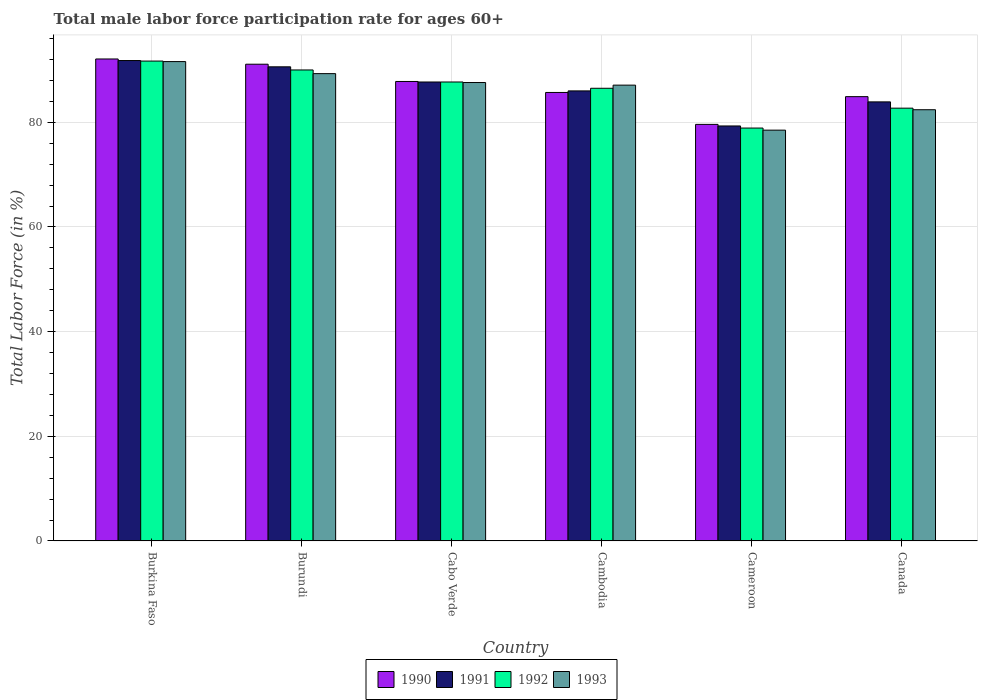How many different coloured bars are there?
Your answer should be very brief. 4. Are the number of bars per tick equal to the number of legend labels?
Offer a terse response. Yes. Are the number of bars on each tick of the X-axis equal?
Provide a succinct answer. Yes. How many bars are there on the 1st tick from the left?
Provide a short and direct response. 4. How many bars are there on the 3rd tick from the right?
Provide a short and direct response. 4. What is the label of the 1st group of bars from the left?
Offer a very short reply. Burkina Faso. What is the male labor force participation rate in 1991 in Burundi?
Your response must be concise. 90.6. Across all countries, what is the maximum male labor force participation rate in 1993?
Give a very brief answer. 91.6. Across all countries, what is the minimum male labor force participation rate in 1993?
Your answer should be very brief. 78.5. In which country was the male labor force participation rate in 1991 maximum?
Your answer should be compact. Burkina Faso. In which country was the male labor force participation rate in 1992 minimum?
Make the answer very short. Cameroon. What is the total male labor force participation rate in 1991 in the graph?
Make the answer very short. 519.3. What is the difference between the male labor force participation rate in 1991 in Cambodia and that in Cameroon?
Keep it short and to the point. 6.7. What is the difference between the male labor force participation rate in 1992 in Cabo Verde and the male labor force participation rate in 1993 in Canada?
Offer a very short reply. 5.3. What is the average male labor force participation rate in 1991 per country?
Offer a terse response. 86.55. What is the ratio of the male labor force participation rate in 1990 in Cabo Verde to that in Canada?
Offer a very short reply. 1.03. Is the male labor force participation rate in 1993 in Burundi less than that in Cameroon?
Your response must be concise. No. Is the difference between the male labor force participation rate in 1992 in Burkina Faso and Cameroon greater than the difference between the male labor force participation rate in 1991 in Burkina Faso and Cameroon?
Offer a terse response. Yes. What is the difference between the highest and the second highest male labor force participation rate in 1992?
Offer a terse response. -1.7. What is the difference between the highest and the lowest male labor force participation rate in 1993?
Your answer should be compact. 13.1. Is it the case that in every country, the sum of the male labor force participation rate in 1992 and male labor force participation rate in 1990 is greater than the sum of male labor force participation rate in 1993 and male labor force participation rate in 1991?
Offer a very short reply. No. What does the 1st bar from the left in Cabo Verde represents?
Provide a short and direct response. 1990. How many countries are there in the graph?
Keep it short and to the point. 6. What is the difference between two consecutive major ticks on the Y-axis?
Provide a succinct answer. 20. Does the graph contain grids?
Keep it short and to the point. Yes. What is the title of the graph?
Keep it short and to the point. Total male labor force participation rate for ages 60+. Does "2003" appear as one of the legend labels in the graph?
Provide a short and direct response. No. What is the label or title of the Y-axis?
Provide a short and direct response. Total Labor Force (in %). What is the Total Labor Force (in %) of 1990 in Burkina Faso?
Make the answer very short. 92.1. What is the Total Labor Force (in %) of 1991 in Burkina Faso?
Offer a terse response. 91.8. What is the Total Labor Force (in %) of 1992 in Burkina Faso?
Ensure brevity in your answer.  91.7. What is the Total Labor Force (in %) in 1993 in Burkina Faso?
Give a very brief answer. 91.6. What is the Total Labor Force (in %) of 1990 in Burundi?
Your answer should be very brief. 91.1. What is the Total Labor Force (in %) of 1991 in Burundi?
Ensure brevity in your answer.  90.6. What is the Total Labor Force (in %) in 1993 in Burundi?
Offer a terse response. 89.3. What is the Total Labor Force (in %) of 1990 in Cabo Verde?
Your response must be concise. 87.8. What is the Total Labor Force (in %) in 1991 in Cabo Verde?
Provide a succinct answer. 87.7. What is the Total Labor Force (in %) in 1992 in Cabo Verde?
Ensure brevity in your answer.  87.7. What is the Total Labor Force (in %) in 1993 in Cabo Verde?
Make the answer very short. 87.6. What is the Total Labor Force (in %) in 1990 in Cambodia?
Provide a succinct answer. 85.7. What is the Total Labor Force (in %) in 1992 in Cambodia?
Offer a terse response. 86.5. What is the Total Labor Force (in %) of 1993 in Cambodia?
Provide a short and direct response. 87.1. What is the Total Labor Force (in %) of 1990 in Cameroon?
Your response must be concise. 79.6. What is the Total Labor Force (in %) of 1991 in Cameroon?
Provide a short and direct response. 79.3. What is the Total Labor Force (in %) in 1992 in Cameroon?
Provide a succinct answer. 78.9. What is the Total Labor Force (in %) in 1993 in Cameroon?
Offer a terse response. 78.5. What is the Total Labor Force (in %) in 1990 in Canada?
Provide a succinct answer. 84.9. What is the Total Labor Force (in %) of 1991 in Canada?
Your answer should be compact. 83.9. What is the Total Labor Force (in %) of 1992 in Canada?
Offer a terse response. 82.7. What is the Total Labor Force (in %) in 1993 in Canada?
Offer a terse response. 82.4. Across all countries, what is the maximum Total Labor Force (in %) of 1990?
Offer a very short reply. 92.1. Across all countries, what is the maximum Total Labor Force (in %) of 1991?
Ensure brevity in your answer.  91.8. Across all countries, what is the maximum Total Labor Force (in %) of 1992?
Your answer should be compact. 91.7. Across all countries, what is the maximum Total Labor Force (in %) in 1993?
Your answer should be compact. 91.6. Across all countries, what is the minimum Total Labor Force (in %) of 1990?
Keep it short and to the point. 79.6. Across all countries, what is the minimum Total Labor Force (in %) in 1991?
Give a very brief answer. 79.3. Across all countries, what is the minimum Total Labor Force (in %) in 1992?
Make the answer very short. 78.9. Across all countries, what is the minimum Total Labor Force (in %) in 1993?
Ensure brevity in your answer.  78.5. What is the total Total Labor Force (in %) of 1990 in the graph?
Provide a succinct answer. 521.2. What is the total Total Labor Force (in %) in 1991 in the graph?
Provide a short and direct response. 519.3. What is the total Total Labor Force (in %) in 1992 in the graph?
Your answer should be very brief. 517.5. What is the total Total Labor Force (in %) of 1993 in the graph?
Make the answer very short. 516.5. What is the difference between the Total Labor Force (in %) of 1990 in Burkina Faso and that in Cabo Verde?
Make the answer very short. 4.3. What is the difference between the Total Labor Force (in %) of 1992 in Burkina Faso and that in Cabo Verde?
Offer a terse response. 4. What is the difference between the Total Labor Force (in %) in 1993 in Burkina Faso and that in Cabo Verde?
Your answer should be compact. 4. What is the difference between the Total Labor Force (in %) of 1990 in Burkina Faso and that in Cambodia?
Your answer should be very brief. 6.4. What is the difference between the Total Labor Force (in %) of 1991 in Burkina Faso and that in Cambodia?
Provide a short and direct response. 5.8. What is the difference between the Total Labor Force (in %) of 1993 in Burkina Faso and that in Cambodia?
Your response must be concise. 4.5. What is the difference between the Total Labor Force (in %) in 1990 in Burkina Faso and that in Cameroon?
Give a very brief answer. 12.5. What is the difference between the Total Labor Force (in %) of 1993 in Burkina Faso and that in Cameroon?
Offer a terse response. 13.1. What is the difference between the Total Labor Force (in %) in 1990 in Burkina Faso and that in Canada?
Your answer should be compact. 7.2. What is the difference between the Total Labor Force (in %) in 1992 in Burkina Faso and that in Canada?
Your response must be concise. 9. What is the difference between the Total Labor Force (in %) of 1990 in Burundi and that in Cabo Verde?
Offer a terse response. 3.3. What is the difference between the Total Labor Force (in %) of 1991 in Burundi and that in Cabo Verde?
Your answer should be compact. 2.9. What is the difference between the Total Labor Force (in %) in 1992 in Burundi and that in Cabo Verde?
Your answer should be very brief. 2.3. What is the difference between the Total Labor Force (in %) in 1993 in Burundi and that in Cabo Verde?
Ensure brevity in your answer.  1.7. What is the difference between the Total Labor Force (in %) in 1990 in Burundi and that in Cambodia?
Ensure brevity in your answer.  5.4. What is the difference between the Total Labor Force (in %) of 1993 in Burundi and that in Cambodia?
Give a very brief answer. 2.2. What is the difference between the Total Labor Force (in %) in 1990 in Burundi and that in Cameroon?
Provide a succinct answer. 11.5. What is the difference between the Total Labor Force (in %) of 1993 in Burundi and that in Canada?
Provide a short and direct response. 6.9. What is the difference between the Total Labor Force (in %) in 1991 in Cabo Verde and that in Cambodia?
Give a very brief answer. 1.7. What is the difference between the Total Labor Force (in %) of 1992 in Cabo Verde and that in Cambodia?
Ensure brevity in your answer.  1.2. What is the difference between the Total Labor Force (in %) of 1993 in Cabo Verde and that in Cambodia?
Provide a short and direct response. 0.5. What is the difference between the Total Labor Force (in %) of 1990 in Cabo Verde and that in Cameroon?
Give a very brief answer. 8.2. What is the difference between the Total Labor Force (in %) of 1991 in Cabo Verde and that in Cameroon?
Give a very brief answer. 8.4. What is the difference between the Total Labor Force (in %) in 1993 in Cabo Verde and that in Cameroon?
Ensure brevity in your answer.  9.1. What is the difference between the Total Labor Force (in %) of 1990 in Cabo Verde and that in Canada?
Give a very brief answer. 2.9. What is the difference between the Total Labor Force (in %) in 1991 in Cabo Verde and that in Canada?
Provide a succinct answer. 3.8. What is the difference between the Total Labor Force (in %) in 1991 in Cambodia and that in Cameroon?
Keep it short and to the point. 6.7. What is the difference between the Total Labor Force (in %) of 1990 in Cambodia and that in Canada?
Keep it short and to the point. 0.8. What is the difference between the Total Labor Force (in %) of 1992 in Cambodia and that in Canada?
Your response must be concise. 3.8. What is the difference between the Total Labor Force (in %) in 1990 in Cameroon and that in Canada?
Keep it short and to the point. -5.3. What is the difference between the Total Labor Force (in %) in 1993 in Cameroon and that in Canada?
Provide a short and direct response. -3.9. What is the difference between the Total Labor Force (in %) in 1991 in Burkina Faso and the Total Labor Force (in %) in 1993 in Burundi?
Ensure brevity in your answer.  2.5. What is the difference between the Total Labor Force (in %) of 1992 in Burkina Faso and the Total Labor Force (in %) of 1993 in Burundi?
Keep it short and to the point. 2.4. What is the difference between the Total Labor Force (in %) in 1990 in Burkina Faso and the Total Labor Force (in %) in 1991 in Cabo Verde?
Make the answer very short. 4.4. What is the difference between the Total Labor Force (in %) in 1990 in Burkina Faso and the Total Labor Force (in %) in 1993 in Cabo Verde?
Your response must be concise. 4.5. What is the difference between the Total Labor Force (in %) of 1992 in Burkina Faso and the Total Labor Force (in %) of 1993 in Cabo Verde?
Ensure brevity in your answer.  4.1. What is the difference between the Total Labor Force (in %) of 1990 in Burkina Faso and the Total Labor Force (in %) of 1991 in Cambodia?
Give a very brief answer. 6.1. What is the difference between the Total Labor Force (in %) of 1991 in Burkina Faso and the Total Labor Force (in %) of 1993 in Cambodia?
Make the answer very short. 4.7. What is the difference between the Total Labor Force (in %) in 1992 in Burkina Faso and the Total Labor Force (in %) in 1993 in Cambodia?
Keep it short and to the point. 4.6. What is the difference between the Total Labor Force (in %) of 1990 in Burkina Faso and the Total Labor Force (in %) of 1991 in Cameroon?
Provide a succinct answer. 12.8. What is the difference between the Total Labor Force (in %) in 1991 in Burkina Faso and the Total Labor Force (in %) in 1992 in Cameroon?
Your answer should be very brief. 12.9. What is the difference between the Total Labor Force (in %) in 1991 in Burkina Faso and the Total Labor Force (in %) in 1993 in Cameroon?
Offer a very short reply. 13.3. What is the difference between the Total Labor Force (in %) in 1990 in Burkina Faso and the Total Labor Force (in %) in 1992 in Canada?
Provide a short and direct response. 9.4. What is the difference between the Total Labor Force (in %) in 1990 in Burkina Faso and the Total Labor Force (in %) in 1993 in Canada?
Provide a short and direct response. 9.7. What is the difference between the Total Labor Force (in %) in 1991 in Burkina Faso and the Total Labor Force (in %) in 1992 in Canada?
Make the answer very short. 9.1. What is the difference between the Total Labor Force (in %) in 1990 in Burundi and the Total Labor Force (in %) in 1993 in Cabo Verde?
Make the answer very short. 3.5. What is the difference between the Total Labor Force (in %) in 1991 in Burundi and the Total Labor Force (in %) in 1992 in Cabo Verde?
Offer a terse response. 2.9. What is the difference between the Total Labor Force (in %) in 1990 in Burundi and the Total Labor Force (in %) in 1992 in Cambodia?
Your response must be concise. 4.6. What is the difference between the Total Labor Force (in %) of 1991 in Burundi and the Total Labor Force (in %) of 1992 in Cambodia?
Provide a succinct answer. 4.1. What is the difference between the Total Labor Force (in %) in 1990 in Burundi and the Total Labor Force (in %) in 1991 in Cameroon?
Your answer should be very brief. 11.8. What is the difference between the Total Labor Force (in %) in 1992 in Burundi and the Total Labor Force (in %) in 1993 in Cameroon?
Offer a terse response. 11.5. What is the difference between the Total Labor Force (in %) of 1990 in Burundi and the Total Labor Force (in %) of 1991 in Canada?
Make the answer very short. 7.2. What is the difference between the Total Labor Force (in %) of 1990 in Burundi and the Total Labor Force (in %) of 1992 in Canada?
Make the answer very short. 8.4. What is the difference between the Total Labor Force (in %) in 1990 in Burundi and the Total Labor Force (in %) in 1993 in Canada?
Offer a very short reply. 8.7. What is the difference between the Total Labor Force (in %) in 1990 in Cabo Verde and the Total Labor Force (in %) in 1991 in Cameroon?
Provide a short and direct response. 8.5. What is the difference between the Total Labor Force (in %) of 1990 in Cabo Verde and the Total Labor Force (in %) of 1992 in Cameroon?
Your answer should be compact. 8.9. What is the difference between the Total Labor Force (in %) of 1991 in Cabo Verde and the Total Labor Force (in %) of 1992 in Cameroon?
Keep it short and to the point. 8.8. What is the difference between the Total Labor Force (in %) in 1990 in Cabo Verde and the Total Labor Force (in %) in 1991 in Canada?
Your response must be concise. 3.9. What is the difference between the Total Labor Force (in %) in 1990 in Cambodia and the Total Labor Force (in %) in 1993 in Cameroon?
Make the answer very short. 7.2. What is the difference between the Total Labor Force (in %) of 1991 in Cambodia and the Total Labor Force (in %) of 1992 in Cameroon?
Offer a terse response. 7.1. What is the difference between the Total Labor Force (in %) in 1992 in Cambodia and the Total Labor Force (in %) in 1993 in Cameroon?
Your response must be concise. 8. What is the difference between the Total Labor Force (in %) in 1990 in Cambodia and the Total Labor Force (in %) in 1991 in Canada?
Make the answer very short. 1.8. What is the difference between the Total Labor Force (in %) of 1990 in Cambodia and the Total Labor Force (in %) of 1992 in Canada?
Your response must be concise. 3. What is the difference between the Total Labor Force (in %) of 1990 in Cambodia and the Total Labor Force (in %) of 1993 in Canada?
Your answer should be compact. 3.3. What is the difference between the Total Labor Force (in %) in 1991 in Cambodia and the Total Labor Force (in %) in 1992 in Canada?
Offer a terse response. 3.3. What is the difference between the Total Labor Force (in %) of 1991 in Cambodia and the Total Labor Force (in %) of 1993 in Canada?
Provide a short and direct response. 3.6. What is the difference between the Total Labor Force (in %) of 1992 in Cambodia and the Total Labor Force (in %) of 1993 in Canada?
Your answer should be very brief. 4.1. What is the difference between the Total Labor Force (in %) of 1990 in Cameroon and the Total Labor Force (in %) of 1991 in Canada?
Keep it short and to the point. -4.3. What is the difference between the Total Labor Force (in %) of 1990 in Cameroon and the Total Labor Force (in %) of 1992 in Canada?
Offer a terse response. -3.1. What is the difference between the Total Labor Force (in %) of 1990 in Cameroon and the Total Labor Force (in %) of 1993 in Canada?
Your response must be concise. -2.8. What is the average Total Labor Force (in %) of 1990 per country?
Offer a very short reply. 86.87. What is the average Total Labor Force (in %) of 1991 per country?
Provide a succinct answer. 86.55. What is the average Total Labor Force (in %) in 1992 per country?
Provide a succinct answer. 86.25. What is the average Total Labor Force (in %) of 1993 per country?
Provide a short and direct response. 86.08. What is the difference between the Total Labor Force (in %) of 1990 and Total Labor Force (in %) of 1991 in Burundi?
Your answer should be very brief. 0.5. What is the difference between the Total Labor Force (in %) of 1990 and Total Labor Force (in %) of 1992 in Burundi?
Keep it short and to the point. 1.1. What is the difference between the Total Labor Force (in %) of 1990 and Total Labor Force (in %) of 1993 in Burundi?
Provide a short and direct response. 1.8. What is the difference between the Total Labor Force (in %) of 1990 and Total Labor Force (in %) of 1991 in Cabo Verde?
Provide a succinct answer. 0.1. What is the difference between the Total Labor Force (in %) in 1990 and Total Labor Force (in %) in 1992 in Cabo Verde?
Make the answer very short. 0.1. What is the difference between the Total Labor Force (in %) of 1991 and Total Labor Force (in %) of 1993 in Cabo Verde?
Your answer should be compact. 0.1. What is the difference between the Total Labor Force (in %) of 1992 and Total Labor Force (in %) of 1993 in Cabo Verde?
Offer a very short reply. 0.1. What is the difference between the Total Labor Force (in %) in 1990 and Total Labor Force (in %) in 1993 in Cambodia?
Make the answer very short. -1.4. What is the difference between the Total Labor Force (in %) in 1991 and Total Labor Force (in %) in 1992 in Cambodia?
Your answer should be very brief. -0.5. What is the difference between the Total Labor Force (in %) in 1992 and Total Labor Force (in %) in 1993 in Cambodia?
Provide a short and direct response. -0.6. What is the difference between the Total Labor Force (in %) in 1991 and Total Labor Force (in %) in 1993 in Cameroon?
Your answer should be very brief. 0.8. What is the difference between the Total Labor Force (in %) in 1990 and Total Labor Force (in %) in 1991 in Canada?
Your response must be concise. 1. What is the difference between the Total Labor Force (in %) in 1990 and Total Labor Force (in %) in 1992 in Canada?
Provide a succinct answer. 2.2. What is the difference between the Total Labor Force (in %) in 1990 and Total Labor Force (in %) in 1993 in Canada?
Your answer should be very brief. 2.5. What is the ratio of the Total Labor Force (in %) in 1990 in Burkina Faso to that in Burundi?
Keep it short and to the point. 1.01. What is the ratio of the Total Labor Force (in %) in 1991 in Burkina Faso to that in Burundi?
Provide a succinct answer. 1.01. What is the ratio of the Total Labor Force (in %) in 1992 in Burkina Faso to that in Burundi?
Your response must be concise. 1.02. What is the ratio of the Total Labor Force (in %) in 1993 in Burkina Faso to that in Burundi?
Ensure brevity in your answer.  1.03. What is the ratio of the Total Labor Force (in %) of 1990 in Burkina Faso to that in Cabo Verde?
Offer a terse response. 1.05. What is the ratio of the Total Labor Force (in %) of 1991 in Burkina Faso to that in Cabo Verde?
Your response must be concise. 1.05. What is the ratio of the Total Labor Force (in %) in 1992 in Burkina Faso to that in Cabo Verde?
Your answer should be very brief. 1.05. What is the ratio of the Total Labor Force (in %) of 1993 in Burkina Faso to that in Cabo Verde?
Your answer should be very brief. 1.05. What is the ratio of the Total Labor Force (in %) of 1990 in Burkina Faso to that in Cambodia?
Offer a terse response. 1.07. What is the ratio of the Total Labor Force (in %) of 1991 in Burkina Faso to that in Cambodia?
Keep it short and to the point. 1.07. What is the ratio of the Total Labor Force (in %) in 1992 in Burkina Faso to that in Cambodia?
Ensure brevity in your answer.  1.06. What is the ratio of the Total Labor Force (in %) of 1993 in Burkina Faso to that in Cambodia?
Offer a terse response. 1.05. What is the ratio of the Total Labor Force (in %) in 1990 in Burkina Faso to that in Cameroon?
Your answer should be very brief. 1.16. What is the ratio of the Total Labor Force (in %) in 1991 in Burkina Faso to that in Cameroon?
Provide a short and direct response. 1.16. What is the ratio of the Total Labor Force (in %) of 1992 in Burkina Faso to that in Cameroon?
Make the answer very short. 1.16. What is the ratio of the Total Labor Force (in %) in 1993 in Burkina Faso to that in Cameroon?
Provide a short and direct response. 1.17. What is the ratio of the Total Labor Force (in %) of 1990 in Burkina Faso to that in Canada?
Provide a succinct answer. 1.08. What is the ratio of the Total Labor Force (in %) of 1991 in Burkina Faso to that in Canada?
Provide a short and direct response. 1.09. What is the ratio of the Total Labor Force (in %) in 1992 in Burkina Faso to that in Canada?
Ensure brevity in your answer.  1.11. What is the ratio of the Total Labor Force (in %) in 1993 in Burkina Faso to that in Canada?
Ensure brevity in your answer.  1.11. What is the ratio of the Total Labor Force (in %) in 1990 in Burundi to that in Cabo Verde?
Provide a short and direct response. 1.04. What is the ratio of the Total Labor Force (in %) of 1991 in Burundi to that in Cabo Verde?
Give a very brief answer. 1.03. What is the ratio of the Total Labor Force (in %) of 1992 in Burundi to that in Cabo Verde?
Provide a succinct answer. 1.03. What is the ratio of the Total Labor Force (in %) in 1993 in Burundi to that in Cabo Verde?
Provide a short and direct response. 1.02. What is the ratio of the Total Labor Force (in %) of 1990 in Burundi to that in Cambodia?
Make the answer very short. 1.06. What is the ratio of the Total Labor Force (in %) in 1991 in Burundi to that in Cambodia?
Offer a terse response. 1.05. What is the ratio of the Total Labor Force (in %) of 1992 in Burundi to that in Cambodia?
Provide a succinct answer. 1.04. What is the ratio of the Total Labor Force (in %) of 1993 in Burundi to that in Cambodia?
Make the answer very short. 1.03. What is the ratio of the Total Labor Force (in %) of 1990 in Burundi to that in Cameroon?
Offer a terse response. 1.14. What is the ratio of the Total Labor Force (in %) in 1991 in Burundi to that in Cameroon?
Ensure brevity in your answer.  1.14. What is the ratio of the Total Labor Force (in %) in 1992 in Burundi to that in Cameroon?
Give a very brief answer. 1.14. What is the ratio of the Total Labor Force (in %) of 1993 in Burundi to that in Cameroon?
Give a very brief answer. 1.14. What is the ratio of the Total Labor Force (in %) in 1990 in Burundi to that in Canada?
Provide a succinct answer. 1.07. What is the ratio of the Total Labor Force (in %) in 1991 in Burundi to that in Canada?
Provide a succinct answer. 1.08. What is the ratio of the Total Labor Force (in %) in 1992 in Burundi to that in Canada?
Make the answer very short. 1.09. What is the ratio of the Total Labor Force (in %) of 1993 in Burundi to that in Canada?
Your answer should be very brief. 1.08. What is the ratio of the Total Labor Force (in %) of 1990 in Cabo Verde to that in Cambodia?
Provide a succinct answer. 1.02. What is the ratio of the Total Labor Force (in %) of 1991 in Cabo Verde to that in Cambodia?
Your answer should be compact. 1.02. What is the ratio of the Total Labor Force (in %) of 1992 in Cabo Verde to that in Cambodia?
Keep it short and to the point. 1.01. What is the ratio of the Total Labor Force (in %) in 1993 in Cabo Verde to that in Cambodia?
Keep it short and to the point. 1.01. What is the ratio of the Total Labor Force (in %) in 1990 in Cabo Verde to that in Cameroon?
Your response must be concise. 1.1. What is the ratio of the Total Labor Force (in %) of 1991 in Cabo Verde to that in Cameroon?
Offer a terse response. 1.11. What is the ratio of the Total Labor Force (in %) in 1992 in Cabo Verde to that in Cameroon?
Provide a short and direct response. 1.11. What is the ratio of the Total Labor Force (in %) of 1993 in Cabo Verde to that in Cameroon?
Make the answer very short. 1.12. What is the ratio of the Total Labor Force (in %) in 1990 in Cabo Verde to that in Canada?
Make the answer very short. 1.03. What is the ratio of the Total Labor Force (in %) of 1991 in Cabo Verde to that in Canada?
Offer a terse response. 1.05. What is the ratio of the Total Labor Force (in %) in 1992 in Cabo Verde to that in Canada?
Provide a succinct answer. 1.06. What is the ratio of the Total Labor Force (in %) of 1993 in Cabo Verde to that in Canada?
Provide a succinct answer. 1.06. What is the ratio of the Total Labor Force (in %) in 1990 in Cambodia to that in Cameroon?
Your answer should be very brief. 1.08. What is the ratio of the Total Labor Force (in %) of 1991 in Cambodia to that in Cameroon?
Provide a short and direct response. 1.08. What is the ratio of the Total Labor Force (in %) of 1992 in Cambodia to that in Cameroon?
Offer a terse response. 1.1. What is the ratio of the Total Labor Force (in %) of 1993 in Cambodia to that in Cameroon?
Keep it short and to the point. 1.11. What is the ratio of the Total Labor Force (in %) in 1990 in Cambodia to that in Canada?
Provide a succinct answer. 1.01. What is the ratio of the Total Labor Force (in %) of 1992 in Cambodia to that in Canada?
Provide a succinct answer. 1.05. What is the ratio of the Total Labor Force (in %) of 1993 in Cambodia to that in Canada?
Ensure brevity in your answer.  1.06. What is the ratio of the Total Labor Force (in %) of 1990 in Cameroon to that in Canada?
Give a very brief answer. 0.94. What is the ratio of the Total Labor Force (in %) of 1991 in Cameroon to that in Canada?
Make the answer very short. 0.95. What is the ratio of the Total Labor Force (in %) in 1992 in Cameroon to that in Canada?
Provide a short and direct response. 0.95. What is the ratio of the Total Labor Force (in %) in 1993 in Cameroon to that in Canada?
Offer a very short reply. 0.95. What is the difference between the highest and the second highest Total Labor Force (in %) of 1993?
Your response must be concise. 2.3. What is the difference between the highest and the lowest Total Labor Force (in %) in 1991?
Provide a succinct answer. 12.5. What is the difference between the highest and the lowest Total Labor Force (in %) in 1993?
Offer a terse response. 13.1. 